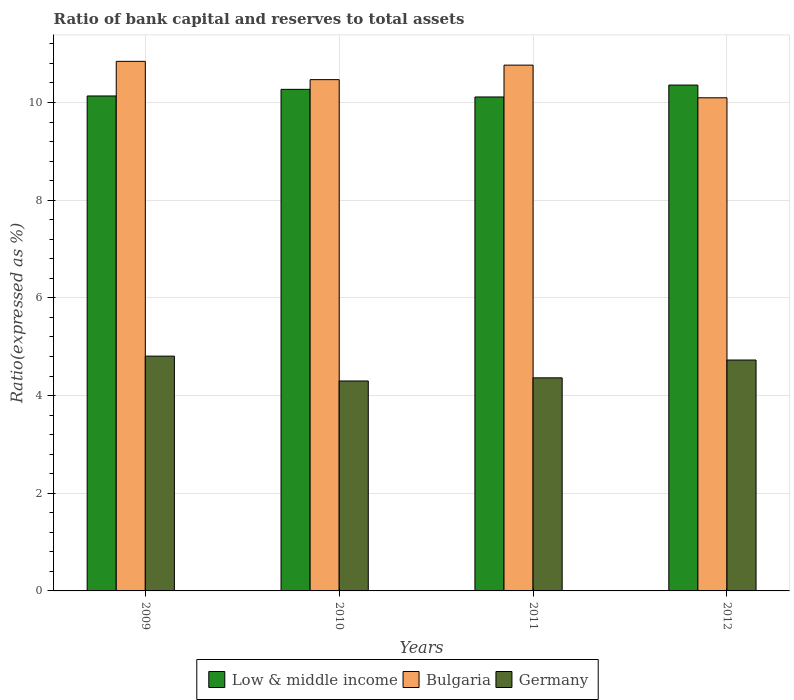How many groups of bars are there?
Offer a terse response. 4. Are the number of bars per tick equal to the number of legend labels?
Ensure brevity in your answer.  Yes. How many bars are there on the 3rd tick from the left?
Ensure brevity in your answer.  3. What is the ratio of bank capital and reserves to total assets in Low & middle income in 2012?
Make the answer very short. 10.36. Across all years, what is the maximum ratio of bank capital and reserves to total assets in Low & middle income?
Your answer should be very brief. 10.36. Across all years, what is the minimum ratio of bank capital and reserves to total assets in Low & middle income?
Give a very brief answer. 10.11. In which year was the ratio of bank capital and reserves to total assets in Low & middle income maximum?
Provide a succinct answer. 2012. In which year was the ratio of bank capital and reserves to total assets in Low & middle income minimum?
Provide a short and direct response. 2011. What is the total ratio of bank capital and reserves to total assets in Germany in the graph?
Provide a short and direct response. 18.2. What is the difference between the ratio of bank capital and reserves to total assets in Low & middle income in 2009 and that in 2011?
Give a very brief answer. 0.02. What is the difference between the ratio of bank capital and reserves to total assets in Germany in 2010 and the ratio of bank capital and reserves to total assets in Bulgaria in 2009?
Your answer should be very brief. -6.54. What is the average ratio of bank capital and reserves to total assets in Germany per year?
Provide a succinct answer. 4.55. In the year 2011, what is the difference between the ratio of bank capital and reserves to total assets in Low & middle income and ratio of bank capital and reserves to total assets in Germany?
Your answer should be very brief. 5.75. What is the ratio of the ratio of bank capital and reserves to total assets in Germany in 2010 to that in 2011?
Offer a very short reply. 0.99. Is the ratio of bank capital and reserves to total assets in Bulgaria in 2010 less than that in 2012?
Give a very brief answer. No. What is the difference between the highest and the second highest ratio of bank capital and reserves to total assets in Bulgaria?
Your answer should be very brief. 0.08. What is the difference between the highest and the lowest ratio of bank capital and reserves to total assets in Low & middle income?
Offer a very short reply. 0.24. In how many years, is the ratio of bank capital and reserves to total assets in Bulgaria greater than the average ratio of bank capital and reserves to total assets in Bulgaria taken over all years?
Your response must be concise. 2. Is the sum of the ratio of bank capital and reserves to total assets in Bulgaria in 2011 and 2012 greater than the maximum ratio of bank capital and reserves to total assets in Germany across all years?
Your answer should be compact. Yes. What does the 2nd bar from the left in 2011 represents?
Your response must be concise. Bulgaria. Are all the bars in the graph horizontal?
Your answer should be very brief. No. What is the difference between two consecutive major ticks on the Y-axis?
Make the answer very short. 2. Does the graph contain any zero values?
Offer a very short reply. No. Does the graph contain grids?
Give a very brief answer. Yes. How many legend labels are there?
Make the answer very short. 3. What is the title of the graph?
Offer a very short reply. Ratio of bank capital and reserves to total assets. What is the label or title of the X-axis?
Your answer should be very brief. Years. What is the label or title of the Y-axis?
Your answer should be very brief. Ratio(expressed as %). What is the Ratio(expressed as %) of Low & middle income in 2009?
Ensure brevity in your answer.  10.13. What is the Ratio(expressed as %) in Bulgaria in 2009?
Ensure brevity in your answer.  10.84. What is the Ratio(expressed as %) of Germany in 2009?
Ensure brevity in your answer.  4.81. What is the Ratio(expressed as %) in Low & middle income in 2010?
Ensure brevity in your answer.  10.27. What is the Ratio(expressed as %) of Bulgaria in 2010?
Your answer should be compact. 10.47. What is the Ratio(expressed as %) of Germany in 2010?
Offer a very short reply. 4.3. What is the Ratio(expressed as %) in Low & middle income in 2011?
Offer a terse response. 10.11. What is the Ratio(expressed as %) in Bulgaria in 2011?
Make the answer very short. 10.76. What is the Ratio(expressed as %) in Germany in 2011?
Give a very brief answer. 4.36. What is the Ratio(expressed as %) of Low & middle income in 2012?
Make the answer very short. 10.36. What is the Ratio(expressed as %) of Bulgaria in 2012?
Give a very brief answer. 10.1. What is the Ratio(expressed as %) in Germany in 2012?
Your answer should be very brief. 4.73. Across all years, what is the maximum Ratio(expressed as %) of Low & middle income?
Your answer should be very brief. 10.36. Across all years, what is the maximum Ratio(expressed as %) in Bulgaria?
Your answer should be very brief. 10.84. Across all years, what is the maximum Ratio(expressed as %) in Germany?
Provide a short and direct response. 4.81. Across all years, what is the minimum Ratio(expressed as %) of Low & middle income?
Keep it short and to the point. 10.11. Across all years, what is the minimum Ratio(expressed as %) in Bulgaria?
Make the answer very short. 10.1. Across all years, what is the minimum Ratio(expressed as %) of Germany?
Your answer should be compact. 4.3. What is the total Ratio(expressed as %) of Low & middle income in the graph?
Provide a short and direct response. 40.87. What is the total Ratio(expressed as %) of Bulgaria in the graph?
Ensure brevity in your answer.  42.17. What is the total Ratio(expressed as %) of Germany in the graph?
Keep it short and to the point. 18.2. What is the difference between the Ratio(expressed as %) in Low & middle income in 2009 and that in 2010?
Your response must be concise. -0.14. What is the difference between the Ratio(expressed as %) of Bulgaria in 2009 and that in 2010?
Provide a short and direct response. 0.37. What is the difference between the Ratio(expressed as %) in Germany in 2009 and that in 2010?
Your response must be concise. 0.51. What is the difference between the Ratio(expressed as %) of Low & middle income in 2009 and that in 2011?
Give a very brief answer. 0.02. What is the difference between the Ratio(expressed as %) in Bulgaria in 2009 and that in 2011?
Keep it short and to the point. 0.08. What is the difference between the Ratio(expressed as %) in Germany in 2009 and that in 2011?
Your response must be concise. 0.44. What is the difference between the Ratio(expressed as %) of Low & middle income in 2009 and that in 2012?
Ensure brevity in your answer.  -0.22. What is the difference between the Ratio(expressed as %) in Bulgaria in 2009 and that in 2012?
Keep it short and to the point. 0.75. What is the difference between the Ratio(expressed as %) in Germany in 2009 and that in 2012?
Ensure brevity in your answer.  0.08. What is the difference between the Ratio(expressed as %) in Low & middle income in 2010 and that in 2011?
Offer a very short reply. 0.16. What is the difference between the Ratio(expressed as %) in Bulgaria in 2010 and that in 2011?
Ensure brevity in your answer.  -0.3. What is the difference between the Ratio(expressed as %) of Germany in 2010 and that in 2011?
Ensure brevity in your answer.  -0.06. What is the difference between the Ratio(expressed as %) in Low & middle income in 2010 and that in 2012?
Ensure brevity in your answer.  -0.09. What is the difference between the Ratio(expressed as %) in Bulgaria in 2010 and that in 2012?
Provide a succinct answer. 0.37. What is the difference between the Ratio(expressed as %) of Germany in 2010 and that in 2012?
Keep it short and to the point. -0.43. What is the difference between the Ratio(expressed as %) of Low & middle income in 2011 and that in 2012?
Your answer should be compact. -0.24. What is the difference between the Ratio(expressed as %) of Bulgaria in 2011 and that in 2012?
Your answer should be compact. 0.67. What is the difference between the Ratio(expressed as %) of Germany in 2011 and that in 2012?
Your response must be concise. -0.36. What is the difference between the Ratio(expressed as %) of Low & middle income in 2009 and the Ratio(expressed as %) of Bulgaria in 2010?
Provide a succinct answer. -0.33. What is the difference between the Ratio(expressed as %) in Low & middle income in 2009 and the Ratio(expressed as %) in Germany in 2010?
Offer a very short reply. 5.84. What is the difference between the Ratio(expressed as %) in Bulgaria in 2009 and the Ratio(expressed as %) in Germany in 2010?
Provide a short and direct response. 6.54. What is the difference between the Ratio(expressed as %) in Low & middle income in 2009 and the Ratio(expressed as %) in Bulgaria in 2011?
Provide a short and direct response. -0.63. What is the difference between the Ratio(expressed as %) in Low & middle income in 2009 and the Ratio(expressed as %) in Germany in 2011?
Your answer should be compact. 5.77. What is the difference between the Ratio(expressed as %) of Bulgaria in 2009 and the Ratio(expressed as %) of Germany in 2011?
Your answer should be very brief. 6.48. What is the difference between the Ratio(expressed as %) in Low & middle income in 2009 and the Ratio(expressed as %) in Bulgaria in 2012?
Your answer should be very brief. 0.04. What is the difference between the Ratio(expressed as %) of Low & middle income in 2009 and the Ratio(expressed as %) of Germany in 2012?
Ensure brevity in your answer.  5.41. What is the difference between the Ratio(expressed as %) of Bulgaria in 2009 and the Ratio(expressed as %) of Germany in 2012?
Your answer should be very brief. 6.11. What is the difference between the Ratio(expressed as %) in Low & middle income in 2010 and the Ratio(expressed as %) in Bulgaria in 2011?
Offer a terse response. -0.5. What is the difference between the Ratio(expressed as %) in Low & middle income in 2010 and the Ratio(expressed as %) in Germany in 2011?
Your answer should be compact. 5.91. What is the difference between the Ratio(expressed as %) of Bulgaria in 2010 and the Ratio(expressed as %) of Germany in 2011?
Give a very brief answer. 6.11. What is the difference between the Ratio(expressed as %) of Low & middle income in 2010 and the Ratio(expressed as %) of Bulgaria in 2012?
Provide a short and direct response. 0.17. What is the difference between the Ratio(expressed as %) in Low & middle income in 2010 and the Ratio(expressed as %) in Germany in 2012?
Provide a succinct answer. 5.54. What is the difference between the Ratio(expressed as %) in Bulgaria in 2010 and the Ratio(expressed as %) in Germany in 2012?
Your answer should be very brief. 5.74. What is the difference between the Ratio(expressed as %) in Low & middle income in 2011 and the Ratio(expressed as %) in Bulgaria in 2012?
Offer a terse response. 0.02. What is the difference between the Ratio(expressed as %) in Low & middle income in 2011 and the Ratio(expressed as %) in Germany in 2012?
Keep it short and to the point. 5.39. What is the difference between the Ratio(expressed as %) in Bulgaria in 2011 and the Ratio(expressed as %) in Germany in 2012?
Offer a very short reply. 6.04. What is the average Ratio(expressed as %) of Low & middle income per year?
Provide a succinct answer. 10.22. What is the average Ratio(expressed as %) of Bulgaria per year?
Provide a short and direct response. 10.54. What is the average Ratio(expressed as %) in Germany per year?
Provide a succinct answer. 4.55. In the year 2009, what is the difference between the Ratio(expressed as %) of Low & middle income and Ratio(expressed as %) of Bulgaria?
Keep it short and to the point. -0.71. In the year 2009, what is the difference between the Ratio(expressed as %) in Low & middle income and Ratio(expressed as %) in Germany?
Ensure brevity in your answer.  5.33. In the year 2009, what is the difference between the Ratio(expressed as %) in Bulgaria and Ratio(expressed as %) in Germany?
Your answer should be very brief. 6.04. In the year 2010, what is the difference between the Ratio(expressed as %) in Low & middle income and Ratio(expressed as %) in Bulgaria?
Ensure brevity in your answer.  -0.2. In the year 2010, what is the difference between the Ratio(expressed as %) in Low & middle income and Ratio(expressed as %) in Germany?
Provide a succinct answer. 5.97. In the year 2010, what is the difference between the Ratio(expressed as %) in Bulgaria and Ratio(expressed as %) in Germany?
Keep it short and to the point. 6.17. In the year 2011, what is the difference between the Ratio(expressed as %) in Low & middle income and Ratio(expressed as %) in Bulgaria?
Make the answer very short. -0.65. In the year 2011, what is the difference between the Ratio(expressed as %) of Low & middle income and Ratio(expressed as %) of Germany?
Your answer should be very brief. 5.75. In the year 2011, what is the difference between the Ratio(expressed as %) in Bulgaria and Ratio(expressed as %) in Germany?
Offer a very short reply. 6.4. In the year 2012, what is the difference between the Ratio(expressed as %) in Low & middle income and Ratio(expressed as %) in Bulgaria?
Ensure brevity in your answer.  0.26. In the year 2012, what is the difference between the Ratio(expressed as %) in Low & middle income and Ratio(expressed as %) in Germany?
Offer a terse response. 5.63. In the year 2012, what is the difference between the Ratio(expressed as %) of Bulgaria and Ratio(expressed as %) of Germany?
Your answer should be very brief. 5.37. What is the ratio of the Ratio(expressed as %) of Low & middle income in 2009 to that in 2010?
Keep it short and to the point. 0.99. What is the ratio of the Ratio(expressed as %) of Bulgaria in 2009 to that in 2010?
Offer a terse response. 1.04. What is the ratio of the Ratio(expressed as %) of Germany in 2009 to that in 2010?
Your answer should be very brief. 1.12. What is the ratio of the Ratio(expressed as %) of Bulgaria in 2009 to that in 2011?
Your answer should be very brief. 1.01. What is the ratio of the Ratio(expressed as %) in Germany in 2009 to that in 2011?
Offer a very short reply. 1.1. What is the ratio of the Ratio(expressed as %) of Low & middle income in 2009 to that in 2012?
Your response must be concise. 0.98. What is the ratio of the Ratio(expressed as %) of Bulgaria in 2009 to that in 2012?
Offer a very short reply. 1.07. What is the ratio of the Ratio(expressed as %) in Germany in 2009 to that in 2012?
Give a very brief answer. 1.02. What is the ratio of the Ratio(expressed as %) in Low & middle income in 2010 to that in 2011?
Provide a succinct answer. 1.02. What is the ratio of the Ratio(expressed as %) in Bulgaria in 2010 to that in 2011?
Keep it short and to the point. 0.97. What is the ratio of the Ratio(expressed as %) of Germany in 2010 to that in 2011?
Your response must be concise. 0.99. What is the ratio of the Ratio(expressed as %) in Low & middle income in 2010 to that in 2012?
Give a very brief answer. 0.99. What is the ratio of the Ratio(expressed as %) of Bulgaria in 2010 to that in 2012?
Provide a succinct answer. 1.04. What is the ratio of the Ratio(expressed as %) in Germany in 2010 to that in 2012?
Your answer should be very brief. 0.91. What is the ratio of the Ratio(expressed as %) of Low & middle income in 2011 to that in 2012?
Your answer should be very brief. 0.98. What is the ratio of the Ratio(expressed as %) in Bulgaria in 2011 to that in 2012?
Your response must be concise. 1.07. What is the ratio of the Ratio(expressed as %) of Germany in 2011 to that in 2012?
Ensure brevity in your answer.  0.92. What is the difference between the highest and the second highest Ratio(expressed as %) in Low & middle income?
Offer a very short reply. 0.09. What is the difference between the highest and the second highest Ratio(expressed as %) in Bulgaria?
Make the answer very short. 0.08. What is the difference between the highest and the second highest Ratio(expressed as %) in Germany?
Make the answer very short. 0.08. What is the difference between the highest and the lowest Ratio(expressed as %) of Low & middle income?
Provide a short and direct response. 0.24. What is the difference between the highest and the lowest Ratio(expressed as %) of Bulgaria?
Give a very brief answer. 0.75. What is the difference between the highest and the lowest Ratio(expressed as %) of Germany?
Provide a short and direct response. 0.51. 